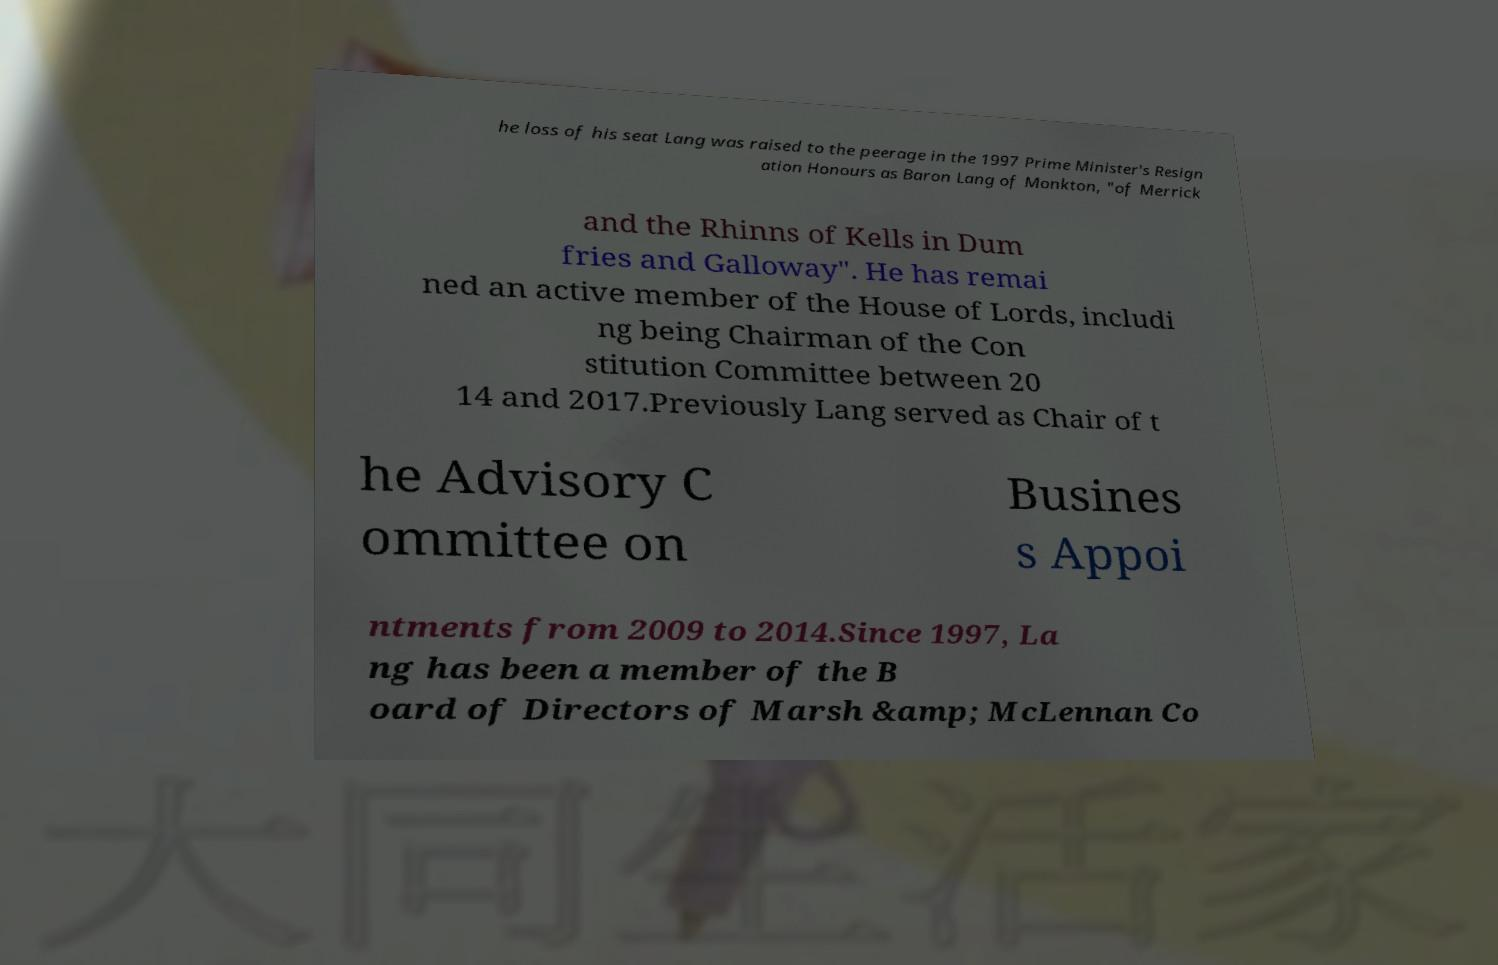Please read and relay the text visible in this image. What does it say? he loss of his seat Lang was raised to the peerage in the 1997 Prime Minister's Resign ation Honours as Baron Lang of Monkton, "of Merrick and the Rhinns of Kells in Dum fries and Galloway". He has remai ned an active member of the House of Lords, includi ng being Chairman of the Con stitution Committee between 20 14 and 2017.Previously Lang served as Chair of t he Advisory C ommittee on Busines s Appoi ntments from 2009 to 2014.Since 1997, La ng has been a member of the B oard of Directors of Marsh &amp; McLennan Co 